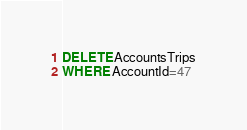<code> <loc_0><loc_0><loc_500><loc_500><_SQL_>DELETE AccountsTrips
WHERE AccountId=47
</code> 